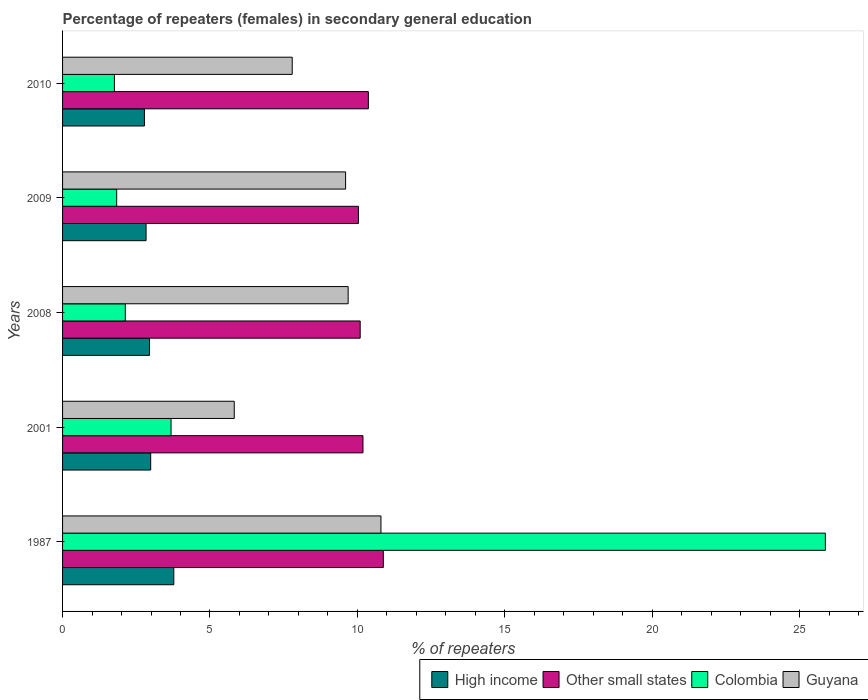How many groups of bars are there?
Your answer should be very brief. 5. Are the number of bars per tick equal to the number of legend labels?
Your answer should be very brief. Yes. Are the number of bars on each tick of the Y-axis equal?
Provide a succinct answer. Yes. How many bars are there on the 3rd tick from the bottom?
Keep it short and to the point. 4. What is the label of the 4th group of bars from the top?
Provide a succinct answer. 2001. What is the percentage of female repeaters in Guyana in 1987?
Offer a very short reply. 10.8. Across all years, what is the maximum percentage of female repeaters in High income?
Offer a terse response. 3.77. Across all years, what is the minimum percentage of female repeaters in Other small states?
Provide a succinct answer. 10.03. What is the total percentage of female repeaters in Colombia in the graph?
Give a very brief answer. 35.27. What is the difference between the percentage of female repeaters in Other small states in 2001 and that in 2010?
Your answer should be compact. -0.18. What is the difference between the percentage of female repeaters in Other small states in 2010 and the percentage of female repeaters in Colombia in 2009?
Give a very brief answer. 8.54. What is the average percentage of female repeaters in Guyana per year?
Offer a terse response. 8.74. In the year 2010, what is the difference between the percentage of female repeaters in Colombia and percentage of female repeaters in Other small states?
Your answer should be compact. -8.61. What is the ratio of the percentage of female repeaters in Colombia in 2001 to that in 2009?
Your response must be concise. 2. Is the difference between the percentage of female repeaters in Colombia in 2008 and 2010 greater than the difference between the percentage of female repeaters in Other small states in 2008 and 2010?
Ensure brevity in your answer.  Yes. What is the difference between the highest and the second highest percentage of female repeaters in High income?
Ensure brevity in your answer.  0.79. What is the difference between the highest and the lowest percentage of female repeaters in High income?
Provide a succinct answer. 1. What does the 4th bar from the top in 2008 represents?
Provide a succinct answer. High income. What does the 4th bar from the bottom in 1987 represents?
Provide a short and direct response. Guyana. How many bars are there?
Offer a terse response. 20. Are all the bars in the graph horizontal?
Keep it short and to the point. Yes. What is the difference between two consecutive major ticks on the X-axis?
Keep it short and to the point. 5. Does the graph contain grids?
Provide a succinct answer. No. What is the title of the graph?
Offer a terse response. Percentage of repeaters (females) in secondary general education. Does "Puerto Rico" appear as one of the legend labels in the graph?
Ensure brevity in your answer.  No. What is the label or title of the X-axis?
Make the answer very short. % of repeaters. What is the % of repeaters in High income in 1987?
Offer a terse response. 3.77. What is the % of repeaters of Other small states in 1987?
Provide a short and direct response. 10.88. What is the % of repeaters of Colombia in 1987?
Give a very brief answer. 25.87. What is the % of repeaters in Guyana in 1987?
Your answer should be compact. 10.8. What is the % of repeaters of High income in 2001?
Provide a short and direct response. 2.99. What is the % of repeaters in Other small states in 2001?
Give a very brief answer. 10.19. What is the % of repeaters of Colombia in 2001?
Offer a terse response. 3.68. What is the % of repeaters of Guyana in 2001?
Provide a succinct answer. 5.82. What is the % of repeaters of High income in 2008?
Your answer should be very brief. 2.95. What is the % of repeaters of Other small states in 2008?
Your answer should be very brief. 10.09. What is the % of repeaters of Colombia in 2008?
Provide a short and direct response. 2.13. What is the % of repeaters in Guyana in 2008?
Your answer should be very brief. 9.69. What is the % of repeaters of High income in 2009?
Your response must be concise. 2.83. What is the % of repeaters of Other small states in 2009?
Your answer should be compact. 10.03. What is the % of repeaters in Colombia in 2009?
Your answer should be very brief. 1.84. What is the % of repeaters of Guyana in 2009?
Offer a terse response. 9.6. What is the % of repeaters of High income in 2010?
Ensure brevity in your answer.  2.78. What is the % of repeaters of Other small states in 2010?
Provide a succinct answer. 10.37. What is the % of repeaters of Colombia in 2010?
Give a very brief answer. 1.76. What is the % of repeaters in Guyana in 2010?
Offer a very short reply. 7.79. Across all years, what is the maximum % of repeaters of High income?
Offer a terse response. 3.77. Across all years, what is the maximum % of repeaters of Other small states?
Keep it short and to the point. 10.88. Across all years, what is the maximum % of repeaters in Colombia?
Provide a succinct answer. 25.87. Across all years, what is the maximum % of repeaters in Guyana?
Provide a succinct answer. 10.8. Across all years, what is the minimum % of repeaters of High income?
Your response must be concise. 2.78. Across all years, what is the minimum % of repeaters in Other small states?
Make the answer very short. 10.03. Across all years, what is the minimum % of repeaters in Colombia?
Make the answer very short. 1.76. Across all years, what is the minimum % of repeaters of Guyana?
Make the answer very short. 5.82. What is the total % of repeaters of High income in the graph?
Your answer should be compact. 15.32. What is the total % of repeaters in Other small states in the graph?
Provide a short and direct response. 51.57. What is the total % of repeaters of Colombia in the graph?
Ensure brevity in your answer.  35.27. What is the total % of repeaters of Guyana in the graph?
Provide a succinct answer. 43.7. What is the difference between the % of repeaters of High income in 1987 and that in 2001?
Your answer should be very brief. 0.79. What is the difference between the % of repeaters in Other small states in 1987 and that in 2001?
Give a very brief answer. 0.69. What is the difference between the % of repeaters of Colombia in 1987 and that in 2001?
Give a very brief answer. 22.19. What is the difference between the % of repeaters of Guyana in 1987 and that in 2001?
Offer a terse response. 4.98. What is the difference between the % of repeaters of High income in 1987 and that in 2008?
Ensure brevity in your answer.  0.82. What is the difference between the % of repeaters of Other small states in 1987 and that in 2008?
Keep it short and to the point. 0.78. What is the difference between the % of repeaters in Colombia in 1987 and that in 2008?
Your answer should be very brief. 23.74. What is the difference between the % of repeaters in Guyana in 1987 and that in 2008?
Make the answer very short. 1.11. What is the difference between the % of repeaters of High income in 1987 and that in 2009?
Your answer should be very brief. 0.94. What is the difference between the % of repeaters of Other small states in 1987 and that in 2009?
Your response must be concise. 0.84. What is the difference between the % of repeaters of Colombia in 1987 and that in 2009?
Your answer should be very brief. 24.04. What is the difference between the % of repeaters of Guyana in 1987 and that in 2009?
Keep it short and to the point. 1.2. What is the difference between the % of repeaters in High income in 1987 and that in 2010?
Provide a succinct answer. 1. What is the difference between the % of repeaters in Other small states in 1987 and that in 2010?
Offer a terse response. 0.51. What is the difference between the % of repeaters of Colombia in 1987 and that in 2010?
Keep it short and to the point. 24.11. What is the difference between the % of repeaters in Guyana in 1987 and that in 2010?
Provide a succinct answer. 3.01. What is the difference between the % of repeaters in High income in 2001 and that in 2008?
Provide a succinct answer. 0.04. What is the difference between the % of repeaters of Other small states in 2001 and that in 2008?
Your response must be concise. 0.09. What is the difference between the % of repeaters in Colombia in 2001 and that in 2008?
Offer a very short reply. 1.55. What is the difference between the % of repeaters of Guyana in 2001 and that in 2008?
Your response must be concise. -3.86. What is the difference between the % of repeaters in High income in 2001 and that in 2009?
Give a very brief answer. 0.16. What is the difference between the % of repeaters of Other small states in 2001 and that in 2009?
Keep it short and to the point. 0.15. What is the difference between the % of repeaters of Colombia in 2001 and that in 2009?
Your answer should be compact. 1.84. What is the difference between the % of repeaters in Guyana in 2001 and that in 2009?
Ensure brevity in your answer.  -3.78. What is the difference between the % of repeaters in High income in 2001 and that in 2010?
Keep it short and to the point. 0.21. What is the difference between the % of repeaters in Other small states in 2001 and that in 2010?
Make the answer very short. -0.18. What is the difference between the % of repeaters in Colombia in 2001 and that in 2010?
Offer a very short reply. 1.92. What is the difference between the % of repeaters in Guyana in 2001 and that in 2010?
Provide a succinct answer. -1.97. What is the difference between the % of repeaters in High income in 2008 and that in 2009?
Ensure brevity in your answer.  0.12. What is the difference between the % of repeaters in Other small states in 2008 and that in 2009?
Keep it short and to the point. 0.06. What is the difference between the % of repeaters in Colombia in 2008 and that in 2009?
Give a very brief answer. 0.29. What is the difference between the % of repeaters in Guyana in 2008 and that in 2009?
Make the answer very short. 0.09. What is the difference between the % of repeaters in High income in 2008 and that in 2010?
Make the answer very short. 0.17. What is the difference between the % of repeaters in Other small states in 2008 and that in 2010?
Give a very brief answer. -0.28. What is the difference between the % of repeaters of Colombia in 2008 and that in 2010?
Offer a very short reply. 0.37. What is the difference between the % of repeaters of Guyana in 2008 and that in 2010?
Provide a succinct answer. 1.9. What is the difference between the % of repeaters in High income in 2009 and that in 2010?
Offer a very short reply. 0.06. What is the difference between the % of repeaters of Other small states in 2009 and that in 2010?
Ensure brevity in your answer.  -0.34. What is the difference between the % of repeaters of Colombia in 2009 and that in 2010?
Provide a short and direct response. 0.08. What is the difference between the % of repeaters in Guyana in 2009 and that in 2010?
Provide a short and direct response. 1.81. What is the difference between the % of repeaters in High income in 1987 and the % of repeaters in Other small states in 2001?
Ensure brevity in your answer.  -6.42. What is the difference between the % of repeaters in High income in 1987 and the % of repeaters in Colombia in 2001?
Ensure brevity in your answer.  0.09. What is the difference between the % of repeaters in High income in 1987 and the % of repeaters in Guyana in 2001?
Offer a very short reply. -2.05. What is the difference between the % of repeaters in Other small states in 1987 and the % of repeaters in Colombia in 2001?
Your response must be concise. 7.2. What is the difference between the % of repeaters in Other small states in 1987 and the % of repeaters in Guyana in 2001?
Provide a succinct answer. 5.06. What is the difference between the % of repeaters of Colombia in 1987 and the % of repeaters of Guyana in 2001?
Your answer should be compact. 20.05. What is the difference between the % of repeaters in High income in 1987 and the % of repeaters in Other small states in 2008?
Keep it short and to the point. -6.32. What is the difference between the % of repeaters in High income in 1987 and the % of repeaters in Colombia in 2008?
Ensure brevity in your answer.  1.65. What is the difference between the % of repeaters of High income in 1987 and the % of repeaters of Guyana in 2008?
Offer a terse response. -5.91. What is the difference between the % of repeaters of Other small states in 1987 and the % of repeaters of Colombia in 2008?
Your answer should be very brief. 8.75. What is the difference between the % of repeaters of Other small states in 1987 and the % of repeaters of Guyana in 2008?
Your answer should be very brief. 1.19. What is the difference between the % of repeaters of Colombia in 1987 and the % of repeaters of Guyana in 2008?
Keep it short and to the point. 16.18. What is the difference between the % of repeaters of High income in 1987 and the % of repeaters of Other small states in 2009?
Your answer should be compact. -6.26. What is the difference between the % of repeaters of High income in 1987 and the % of repeaters of Colombia in 2009?
Keep it short and to the point. 1.94. What is the difference between the % of repeaters of High income in 1987 and the % of repeaters of Guyana in 2009?
Your answer should be compact. -5.83. What is the difference between the % of repeaters of Other small states in 1987 and the % of repeaters of Colombia in 2009?
Ensure brevity in your answer.  9.04. What is the difference between the % of repeaters in Other small states in 1987 and the % of repeaters in Guyana in 2009?
Ensure brevity in your answer.  1.28. What is the difference between the % of repeaters of Colombia in 1987 and the % of repeaters of Guyana in 2009?
Provide a succinct answer. 16.27. What is the difference between the % of repeaters in High income in 1987 and the % of repeaters in Other small states in 2010?
Keep it short and to the point. -6.6. What is the difference between the % of repeaters in High income in 1987 and the % of repeaters in Colombia in 2010?
Provide a short and direct response. 2.02. What is the difference between the % of repeaters of High income in 1987 and the % of repeaters of Guyana in 2010?
Offer a very short reply. -4.02. What is the difference between the % of repeaters in Other small states in 1987 and the % of repeaters in Colombia in 2010?
Give a very brief answer. 9.12. What is the difference between the % of repeaters in Other small states in 1987 and the % of repeaters in Guyana in 2010?
Provide a short and direct response. 3.09. What is the difference between the % of repeaters in Colombia in 1987 and the % of repeaters in Guyana in 2010?
Offer a terse response. 18.08. What is the difference between the % of repeaters of High income in 2001 and the % of repeaters of Other small states in 2008?
Your response must be concise. -7.11. What is the difference between the % of repeaters of High income in 2001 and the % of repeaters of Colombia in 2008?
Your response must be concise. 0.86. What is the difference between the % of repeaters in High income in 2001 and the % of repeaters in Guyana in 2008?
Keep it short and to the point. -6.7. What is the difference between the % of repeaters in Other small states in 2001 and the % of repeaters in Colombia in 2008?
Ensure brevity in your answer.  8.06. What is the difference between the % of repeaters in Other small states in 2001 and the % of repeaters in Guyana in 2008?
Your response must be concise. 0.5. What is the difference between the % of repeaters in Colombia in 2001 and the % of repeaters in Guyana in 2008?
Provide a succinct answer. -6.01. What is the difference between the % of repeaters of High income in 2001 and the % of repeaters of Other small states in 2009?
Ensure brevity in your answer.  -7.05. What is the difference between the % of repeaters of High income in 2001 and the % of repeaters of Colombia in 2009?
Ensure brevity in your answer.  1.15. What is the difference between the % of repeaters of High income in 2001 and the % of repeaters of Guyana in 2009?
Provide a short and direct response. -6.61. What is the difference between the % of repeaters in Other small states in 2001 and the % of repeaters in Colombia in 2009?
Provide a short and direct response. 8.35. What is the difference between the % of repeaters in Other small states in 2001 and the % of repeaters in Guyana in 2009?
Keep it short and to the point. 0.59. What is the difference between the % of repeaters of Colombia in 2001 and the % of repeaters of Guyana in 2009?
Keep it short and to the point. -5.92. What is the difference between the % of repeaters of High income in 2001 and the % of repeaters of Other small states in 2010?
Your response must be concise. -7.38. What is the difference between the % of repeaters of High income in 2001 and the % of repeaters of Colombia in 2010?
Give a very brief answer. 1.23. What is the difference between the % of repeaters of High income in 2001 and the % of repeaters of Guyana in 2010?
Your response must be concise. -4.8. What is the difference between the % of repeaters in Other small states in 2001 and the % of repeaters in Colombia in 2010?
Provide a succinct answer. 8.43. What is the difference between the % of repeaters in Other small states in 2001 and the % of repeaters in Guyana in 2010?
Give a very brief answer. 2.4. What is the difference between the % of repeaters in Colombia in 2001 and the % of repeaters in Guyana in 2010?
Keep it short and to the point. -4.11. What is the difference between the % of repeaters of High income in 2008 and the % of repeaters of Other small states in 2009?
Ensure brevity in your answer.  -7.08. What is the difference between the % of repeaters in High income in 2008 and the % of repeaters in Colombia in 2009?
Keep it short and to the point. 1.11. What is the difference between the % of repeaters of High income in 2008 and the % of repeaters of Guyana in 2009?
Offer a terse response. -6.65. What is the difference between the % of repeaters of Other small states in 2008 and the % of repeaters of Colombia in 2009?
Ensure brevity in your answer.  8.26. What is the difference between the % of repeaters in Other small states in 2008 and the % of repeaters in Guyana in 2009?
Your answer should be compact. 0.49. What is the difference between the % of repeaters in Colombia in 2008 and the % of repeaters in Guyana in 2009?
Your answer should be compact. -7.47. What is the difference between the % of repeaters in High income in 2008 and the % of repeaters in Other small states in 2010?
Make the answer very short. -7.42. What is the difference between the % of repeaters in High income in 2008 and the % of repeaters in Colombia in 2010?
Your answer should be very brief. 1.19. What is the difference between the % of repeaters of High income in 2008 and the % of repeaters of Guyana in 2010?
Offer a very short reply. -4.84. What is the difference between the % of repeaters of Other small states in 2008 and the % of repeaters of Colombia in 2010?
Offer a very short reply. 8.34. What is the difference between the % of repeaters of Other small states in 2008 and the % of repeaters of Guyana in 2010?
Provide a succinct answer. 2.31. What is the difference between the % of repeaters in Colombia in 2008 and the % of repeaters in Guyana in 2010?
Provide a succinct answer. -5.66. What is the difference between the % of repeaters in High income in 2009 and the % of repeaters in Other small states in 2010?
Keep it short and to the point. -7.54. What is the difference between the % of repeaters in High income in 2009 and the % of repeaters in Colombia in 2010?
Offer a terse response. 1.07. What is the difference between the % of repeaters in High income in 2009 and the % of repeaters in Guyana in 2010?
Your answer should be very brief. -4.96. What is the difference between the % of repeaters in Other small states in 2009 and the % of repeaters in Colombia in 2010?
Ensure brevity in your answer.  8.28. What is the difference between the % of repeaters in Other small states in 2009 and the % of repeaters in Guyana in 2010?
Make the answer very short. 2.25. What is the difference between the % of repeaters in Colombia in 2009 and the % of repeaters in Guyana in 2010?
Keep it short and to the point. -5.95. What is the average % of repeaters of High income per year?
Provide a short and direct response. 3.06. What is the average % of repeaters in Other small states per year?
Make the answer very short. 10.31. What is the average % of repeaters of Colombia per year?
Provide a short and direct response. 7.05. What is the average % of repeaters in Guyana per year?
Provide a succinct answer. 8.74. In the year 1987, what is the difference between the % of repeaters of High income and % of repeaters of Other small states?
Provide a short and direct response. -7.11. In the year 1987, what is the difference between the % of repeaters of High income and % of repeaters of Colombia?
Offer a terse response. -22.1. In the year 1987, what is the difference between the % of repeaters of High income and % of repeaters of Guyana?
Provide a short and direct response. -7.02. In the year 1987, what is the difference between the % of repeaters of Other small states and % of repeaters of Colombia?
Offer a terse response. -14.99. In the year 1987, what is the difference between the % of repeaters in Other small states and % of repeaters in Guyana?
Your answer should be compact. 0.08. In the year 1987, what is the difference between the % of repeaters of Colombia and % of repeaters of Guyana?
Offer a terse response. 15.07. In the year 2001, what is the difference between the % of repeaters in High income and % of repeaters in Other small states?
Your answer should be very brief. -7.2. In the year 2001, what is the difference between the % of repeaters in High income and % of repeaters in Colombia?
Offer a terse response. -0.69. In the year 2001, what is the difference between the % of repeaters of High income and % of repeaters of Guyana?
Ensure brevity in your answer.  -2.83. In the year 2001, what is the difference between the % of repeaters of Other small states and % of repeaters of Colombia?
Offer a terse response. 6.51. In the year 2001, what is the difference between the % of repeaters of Other small states and % of repeaters of Guyana?
Provide a succinct answer. 4.37. In the year 2001, what is the difference between the % of repeaters of Colombia and % of repeaters of Guyana?
Keep it short and to the point. -2.14. In the year 2008, what is the difference between the % of repeaters of High income and % of repeaters of Other small states?
Provide a short and direct response. -7.14. In the year 2008, what is the difference between the % of repeaters of High income and % of repeaters of Colombia?
Make the answer very short. 0.82. In the year 2008, what is the difference between the % of repeaters of High income and % of repeaters of Guyana?
Offer a terse response. -6.74. In the year 2008, what is the difference between the % of repeaters in Other small states and % of repeaters in Colombia?
Your response must be concise. 7.97. In the year 2008, what is the difference between the % of repeaters in Other small states and % of repeaters in Guyana?
Offer a very short reply. 0.41. In the year 2008, what is the difference between the % of repeaters of Colombia and % of repeaters of Guyana?
Give a very brief answer. -7.56. In the year 2009, what is the difference between the % of repeaters in High income and % of repeaters in Other small states?
Keep it short and to the point. -7.2. In the year 2009, what is the difference between the % of repeaters in High income and % of repeaters in Colombia?
Offer a terse response. 1. In the year 2009, what is the difference between the % of repeaters of High income and % of repeaters of Guyana?
Your response must be concise. -6.77. In the year 2009, what is the difference between the % of repeaters of Other small states and % of repeaters of Colombia?
Your answer should be compact. 8.2. In the year 2009, what is the difference between the % of repeaters of Other small states and % of repeaters of Guyana?
Provide a short and direct response. 0.43. In the year 2009, what is the difference between the % of repeaters of Colombia and % of repeaters of Guyana?
Give a very brief answer. -7.76. In the year 2010, what is the difference between the % of repeaters in High income and % of repeaters in Other small states?
Provide a succinct answer. -7.6. In the year 2010, what is the difference between the % of repeaters of High income and % of repeaters of Colombia?
Offer a terse response. 1.02. In the year 2010, what is the difference between the % of repeaters in High income and % of repeaters in Guyana?
Offer a terse response. -5.01. In the year 2010, what is the difference between the % of repeaters of Other small states and % of repeaters of Colombia?
Offer a very short reply. 8.61. In the year 2010, what is the difference between the % of repeaters in Other small states and % of repeaters in Guyana?
Your answer should be compact. 2.58. In the year 2010, what is the difference between the % of repeaters in Colombia and % of repeaters in Guyana?
Provide a succinct answer. -6.03. What is the ratio of the % of repeaters of High income in 1987 to that in 2001?
Provide a succinct answer. 1.26. What is the ratio of the % of repeaters of Other small states in 1987 to that in 2001?
Your answer should be very brief. 1.07. What is the ratio of the % of repeaters of Colombia in 1987 to that in 2001?
Give a very brief answer. 7.03. What is the ratio of the % of repeaters in Guyana in 1987 to that in 2001?
Keep it short and to the point. 1.85. What is the ratio of the % of repeaters of High income in 1987 to that in 2008?
Your response must be concise. 1.28. What is the ratio of the % of repeaters in Other small states in 1987 to that in 2008?
Keep it short and to the point. 1.08. What is the ratio of the % of repeaters of Colombia in 1987 to that in 2008?
Keep it short and to the point. 12.16. What is the ratio of the % of repeaters in Guyana in 1987 to that in 2008?
Provide a succinct answer. 1.11. What is the ratio of the % of repeaters of High income in 1987 to that in 2009?
Make the answer very short. 1.33. What is the ratio of the % of repeaters in Other small states in 1987 to that in 2009?
Provide a succinct answer. 1.08. What is the ratio of the % of repeaters of Colombia in 1987 to that in 2009?
Offer a terse response. 14.09. What is the ratio of the % of repeaters of Guyana in 1987 to that in 2009?
Offer a very short reply. 1.12. What is the ratio of the % of repeaters in High income in 1987 to that in 2010?
Offer a very short reply. 1.36. What is the ratio of the % of repeaters of Other small states in 1987 to that in 2010?
Ensure brevity in your answer.  1.05. What is the ratio of the % of repeaters of Colombia in 1987 to that in 2010?
Keep it short and to the point. 14.71. What is the ratio of the % of repeaters in Guyana in 1987 to that in 2010?
Your answer should be compact. 1.39. What is the ratio of the % of repeaters in Other small states in 2001 to that in 2008?
Your answer should be very brief. 1.01. What is the ratio of the % of repeaters in Colombia in 2001 to that in 2008?
Give a very brief answer. 1.73. What is the ratio of the % of repeaters of Guyana in 2001 to that in 2008?
Make the answer very short. 0.6. What is the ratio of the % of repeaters in High income in 2001 to that in 2009?
Make the answer very short. 1.06. What is the ratio of the % of repeaters in Other small states in 2001 to that in 2009?
Your answer should be very brief. 1.02. What is the ratio of the % of repeaters of Colombia in 2001 to that in 2009?
Offer a very short reply. 2. What is the ratio of the % of repeaters of Guyana in 2001 to that in 2009?
Provide a short and direct response. 0.61. What is the ratio of the % of repeaters in High income in 2001 to that in 2010?
Your answer should be compact. 1.08. What is the ratio of the % of repeaters of Other small states in 2001 to that in 2010?
Your answer should be very brief. 0.98. What is the ratio of the % of repeaters of Colombia in 2001 to that in 2010?
Provide a succinct answer. 2.09. What is the ratio of the % of repeaters of Guyana in 2001 to that in 2010?
Your answer should be very brief. 0.75. What is the ratio of the % of repeaters of High income in 2008 to that in 2009?
Make the answer very short. 1.04. What is the ratio of the % of repeaters in Other small states in 2008 to that in 2009?
Give a very brief answer. 1.01. What is the ratio of the % of repeaters in Colombia in 2008 to that in 2009?
Your answer should be compact. 1.16. What is the ratio of the % of repeaters in High income in 2008 to that in 2010?
Ensure brevity in your answer.  1.06. What is the ratio of the % of repeaters in Other small states in 2008 to that in 2010?
Your response must be concise. 0.97. What is the ratio of the % of repeaters in Colombia in 2008 to that in 2010?
Your response must be concise. 1.21. What is the ratio of the % of repeaters of Guyana in 2008 to that in 2010?
Ensure brevity in your answer.  1.24. What is the ratio of the % of repeaters of High income in 2009 to that in 2010?
Your response must be concise. 1.02. What is the ratio of the % of repeaters of Other small states in 2009 to that in 2010?
Keep it short and to the point. 0.97. What is the ratio of the % of repeaters in Colombia in 2009 to that in 2010?
Keep it short and to the point. 1.04. What is the ratio of the % of repeaters of Guyana in 2009 to that in 2010?
Offer a terse response. 1.23. What is the difference between the highest and the second highest % of repeaters of High income?
Offer a very short reply. 0.79. What is the difference between the highest and the second highest % of repeaters of Other small states?
Your answer should be very brief. 0.51. What is the difference between the highest and the second highest % of repeaters in Colombia?
Give a very brief answer. 22.19. What is the difference between the highest and the second highest % of repeaters in Guyana?
Keep it short and to the point. 1.11. What is the difference between the highest and the lowest % of repeaters in Other small states?
Your response must be concise. 0.84. What is the difference between the highest and the lowest % of repeaters of Colombia?
Keep it short and to the point. 24.11. What is the difference between the highest and the lowest % of repeaters in Guyana?
Keep it short and to the point. 4.98. 